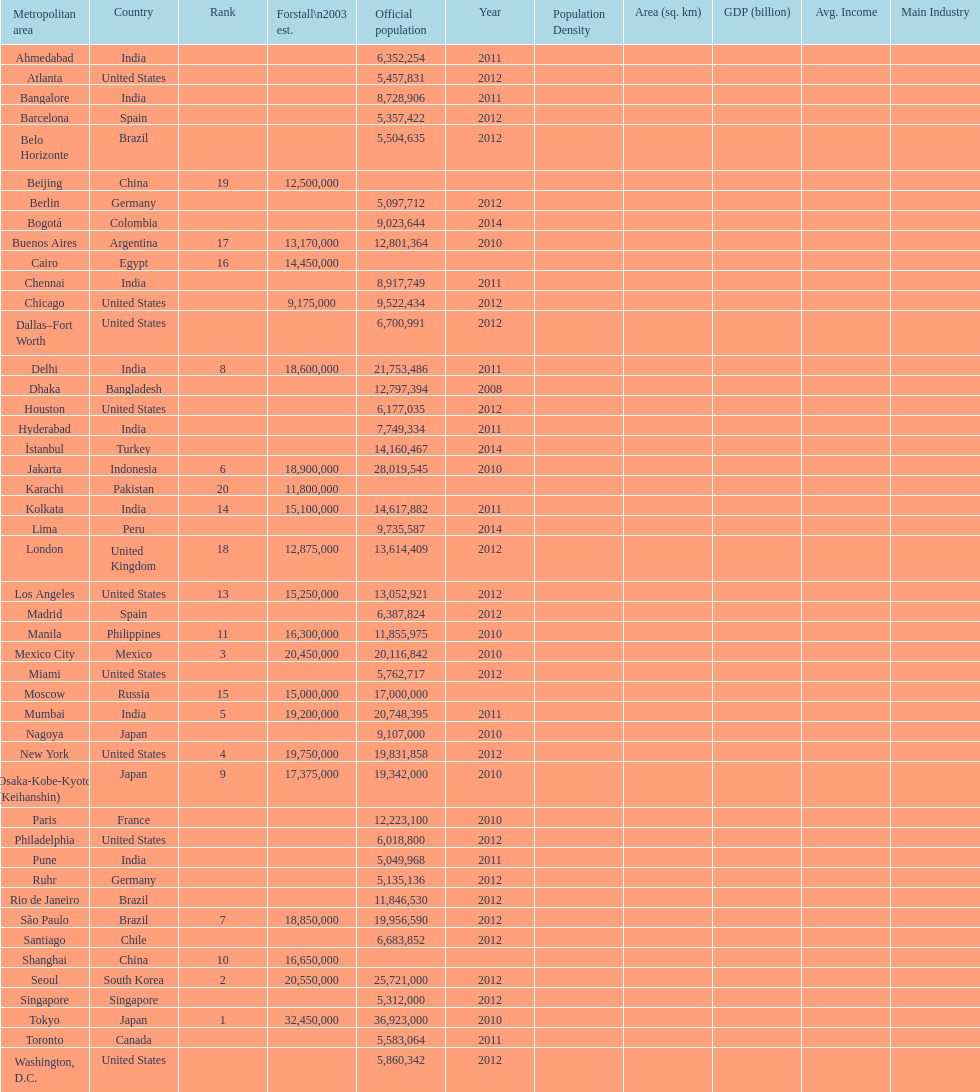How many cities are in the united states? 9. 